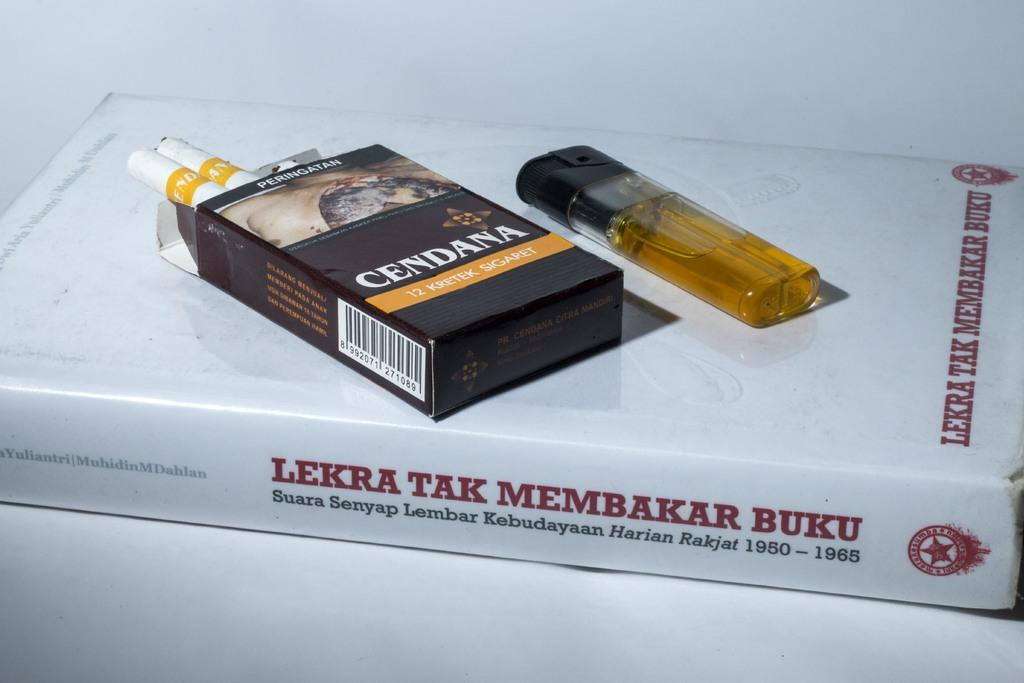<image>
Offer a succinct explanation of the picture presented. A pack of Cendana cigarettes and a lighter lay on a book. 